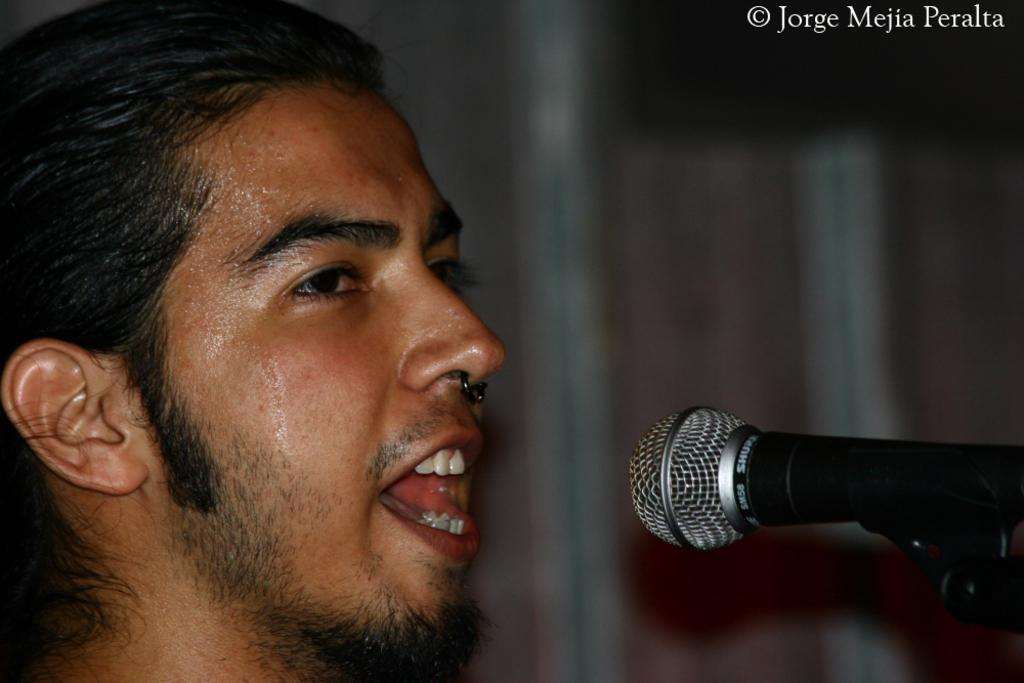What is the main subject in the foreground of the image? There is a man's face in the foreground of the image. What object is in front of the man? There is a mic in front of the man. How would you describe the background of the image? The background of the image is blurred. What type of haircut does the man have in the image? The image does not show the man's haircut, as it only features his face. What kind of destruction can be seen in the image? There is no destruction present in the image; it only features a man's face and a mic. 